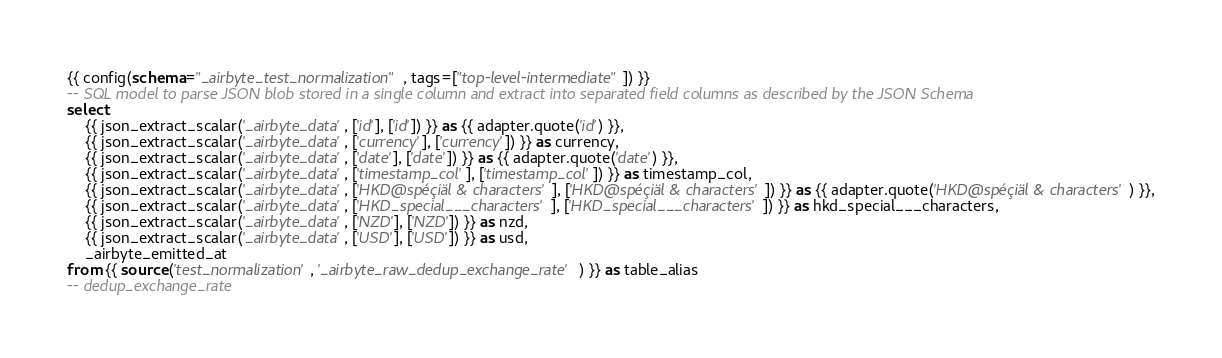<code> <loc_0><loc_0><loc_500><loc_500><_SQL_>{{ config(schema="_airbyte_test_normalization", tags=["top-level-intermediate"]) }}
-- SQL model to parse JSON blob stored in a single column and extract into separated field columns as described by the JSON Schema
select
    {{ json_extract_scalar('_airbyte_data', ['id'], ['id']) }} as {{ adapter.quote('id') }},
    {{ json_extract_scalar('_airbyte_data', ['currency'], ['currency']) }} as currency,
    {{ json_extract_scalar('_airbyte_data', ['date'], ['date']) }} as {{ adapter.quote('date') }},
    {{ json_extract_scalar('_airbyte_data', ['timestamp_col'], ['timestamp_col']) }} as timestamp_col,
    {{ json_extract_scalar('_airbyte_data', ['HKD@spéçiäl & characters'], ['HKD@spéçiäl & characters']) }} as {{ adapter.quote('HKD@spéçiäl & characters') }},
    {{ json_extract_scalar('_airbyte_data', ['HKD_special___characters'], ['HKD_special___characters']) }} as hkd_special___characters,
    {{ json_extract_scalar('_airbyte_data', ['NZD'], ['NZD']) }} as nzd,
    {{ json_extract_scalar('_airbyte_data', ['USD'], ['USD']) }} as usd,
    _airbyte_emitted_at
from {{ source('test_normalization', '_airbyte_raw_dedup_exchange_rate') }} as table_alias
-- dedup_exchange_rate

</code> 